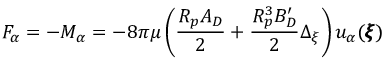Convert formula to latex. <formula><loc_0><loc_0><loc_500><loc_500>F _ { \alpha } = - M _ { \alpha } = - 8 \pi \mu \left ( \frac { R _ { p } A _ { D } } { 2 } + \frac { R _ { p } ^ { 3 } B _ { D } ^ { \prime } } { 2 } \Delta _ { \xi } \right ) u _ { \alpha } ( { \pm b \xi } )</formula> 